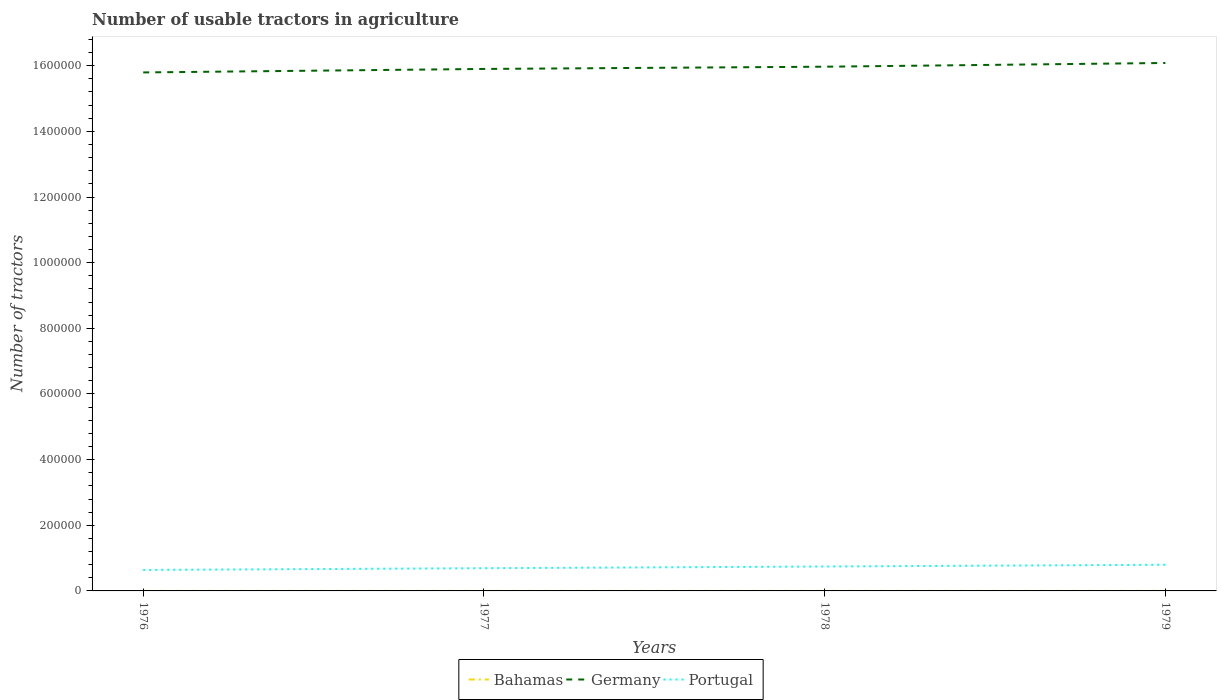How many different coloured lines are there?
Your response must be concise. 3. Does the line corresponding to Germany intersect with the line corresponding to Bahamas?
Your response must be concise. No. Is the number of lines equal to the number of legend labels?
Offer a terse response. Yes. Across all years, what is the maximum number of usable tractors in agriculture in Portugal?
Your answer should be very brief. 6.39e+04. In which year was the number of usable tractors in agriculture in Germany maximum?
Ensure brevity in your answer.  1976. What is the difference between the highest and the second highest number of usable tractors in agriculture in Portugal?
Keep it short and to the point. 1.58e+04. What is the difference between two consecutive major ticks on the Y-axis?
Give a very brief answer. 2.00e+05. Are the values on the major ticks of Y-axis written in scientific E-notation?
Your answer should be very brief. No. Does the graph contain any zero values?
Provide a short and direct response. No. Does the graph contain grids?
Keep it short and to the point. No. How many legend labels are there?
Provide a succinct answer. 3. What is the title of the graph?
Your answer should be very brief. Number of usable tractors in agriculture. What is the label or title of the X-axis?
Provide a short and direct response. Years. What is the label or title of the Y-axis?
Give a very brief answer. Number of tractors. What is the Number of tractors of Germany in 1976?
Offer a very short reply. 1.58e+06. What is the Number of tractors of Portugal in 1976?
Provide a succinct answer. 6.39e+04. What is the Number of tractors of Germany in 1977?
Offer a terse response. 1.59e+06. What is the Number of tractors of Portugal in 1977?
Offer a terse response. 6.92e+04. What is the Number of tractors in Bahamas in 1978?
Your answer should be very brief. 77. What is the Number of tractors of Germany in 1978?
Make the answer very short. 1.60e+06. What is the Number of tractors of Portugal in 1978?
Give a very brief answer. 7.44e+04. What is the Number of tractors of Germany in 1979?
Your response must be concise. 1.61e+06. What is the Number of tractors in Portugal in 1979?
Provide a succinct answer. 7.97e+04. Across all years, what is the maximum Number of tractors of Germany?
Ensure brevity in your answer.  1.61e+06. Across all years, what is the maximum Number of tractors of Portugal?
Offer a terse response. 7.97e+04. Across all years, what is the minimum Number of tractors in Germany?
Make the answer very short. 1.58e+06. Across all years, what is the minimum Number of tractors of Portugal?
Provide a succinct answer. 6.39e+04. What is the total Number of tractors in Bahamas in the graph?
Offer a very short reply. 302. What is the total Number of tractors of Germany in the graph?
Your response must be concise. 6.37e+06. What is the total Number of tractors in Portugal in the graph?
Offer a terse response. 2.87e+05. What is the difference between the Number of tractors in Germany in 1976 and that in 1977?
Offer a very short reply. -1.06e+04. What is the difference between the Number of tractors of Portugal in 1976 and that in 1977?
Offer a very short reply. -5300. What is the difference between the Number of tractors of Bahamas in 1976 and that in 1978?
Make the answer very short. -6. What is the difference between the Number of tractors in Germany in 1976 and that in 1978?
Make the answer very short. -1.74e+04. What is the difference between the Number of tractors in Portugal in 1976 and that in 1978?
Provide a short and direct response. -1.05e+04. What is the difference between the Number of tractors in Germany in 1976 and that in 1979?
Ensure brevity in your answer.  -2.88e+04. What is the difference between the Number of tractors in Portugal in 1976 and that in 1979?
Make the answer very short. -1.58e+04. What is the difference between the Number of tractors of Bahamas in 1977 and that in 1978?
Offer a very short reply. -3. What is the difference between the Number of tractors of Germany in 1977 and that in 1978?
Your response must be concise. -6809. What is the difference between the Number of tractors in Portugal in 1977 and that in 1978?
Offer a very short reply. -5200. What is the difference between the Number of tractors in Germany in 1977 and that in 1979?
Make the answer very short. -1.82e+04. What is the difference between the Number of tractors of Portugal in 1977 and that in 1979?
Provide a short and direct response. -1.05e+04. What is the difference between the Number of tractors of Bahamas in 1978 and that in 1979?
Your answer should be compact. -3. What is the difference between the Number of tractors in Germany in 1978 and that in 1979?
Provide a succinct answer. -1.14e+04. What is the difference between the Number of tractors in Portugal in 1978 and that in 1979?
Provide a short and direct response. -5300. What is the difference between the Number of tractors of Bahamas in 1976 and the Number of tractors of Germany in 1977?
Your answer should be compact. -1.59e+06. What is the difference between the Number of tractors of Bahamas in 1976 and the Number of tractors of Portugal in 1977?
Your answer should be very brief. -6.91e+04. What is the difference between the Number of tractors of Germany in 1976 and the Number of tractors of Portugal in 1977?
Give a very brief answer. 1.51e+06. What is the difference between the Number of tractors of Bahamas in 1976 and the Number of tractors of Germany in 1978?
Ensure brevity in your answer.  -1.60e+06. What is the difference between the Number of tractors of Bahamas in 1976 and the Number of tractors of Portugal in 1978?
Provide a short and direct response. -7.43e+04. What is the difference between the Number of tractors of Germany in 1976 and the Number of tractors of Portugal in 1978?
Provide a short and direct response. 1.51e+06. What is the difference between the Number of tractors in Bahamas in 1976 and the Number of tractors in Germany in 1979?
Make the answer very short. -1.61e+06. What is the difference between the Number of tractors of Bahamas in 1976 and the Number of tractors of Portugal in 1979?
Offer a very short reply. -7.96e+04. What is the difference between the Number of tractors in Germany in 1976 and the Number of tractors in Portugal in 1979?
Make the answer very short. 1.50e+06. What is the difference between the Number of tractors of Bahamas in 1977 and the Number of tractors of Germany in 1978?
Your answer should be compact. -1.60e+06. What is the difference between the Number of tractors in Bahamas in 1977 and the Number of tractors in Portugal in 1978?
Offer a terse response. -7.43e+04. What is the difference between the Number of tractors of Germany in 1977 and the Number of tractors of Portugal in 1978?
Your answer should be compact. 1.52e+06. What is the difference between the Number of tractors in Bahamas in 1977 and the Number of tractors in Germany in 1979?
Offer a very short reply. -1.61e+06. What is the difference between the Number of tractors of Bahamas in 1977 and the Number of tractors of Portugal in 1979?
Your answer should be very brief. -7.96e+04. What is the difference between the Number of tractors in Germany in 1977 and the Number of tractors in Portugal in 1979?
Offer a very short reply. 1.51e+06. What is the difference between the Number of tractors of Bahamas in 1978 and the Number of tractors of Germany in 1979?
Provide a succinct answer. -1.61e+06. What is the difference between the Number of tractors in Bahamas in 1978 and the Number of tractors in Portugal in 1979?
Provide a succinct answer. -7.96e+04. What is the difference between the Number of tractors in Germany in 1978 and the Number of tractors in Portugal in 1979?
Your answer should be very brief. 1.52e+06. What is the average Number of tractors in Bahamas per year?
Provide a succinct answer. 75.5. What is the average Number of tractors of Germany per year?
Your response must be concise. 1.59e+06. What is the average Number of tractors of Portugal per year?
Offer a terse response. 7.18e+04. In the year 1976, what is the difference between the Number of tractors of Bahamas and Number of tractors of Germany?
Your answer should be very brief. -1.58e+06. In the year 1976, what is the difference between the Number of tractors in Bahamas and Number of tractors in Portugal?
Provide a short and direct response. -6.38e+04. In the year 1976, what is the difference between the Number of tractors of Germany and Number of tractors of Portugal?
Your answer should be compact. 1.52e+06. In the year 1977, what is the difference between the Number of tractors of Bahamas and Number of tractors of Germany?
Your answer should be compact. -1.59e+06. In the year 1977, what is the difference between the Number of tractors of Bahamas and Number of tractors of Portugal?
Offer a terse response. -6.91e+04. In the year 1977, what is the difference between the Number of tractors of Germany and Number of tractors of Portugal?
Ensure brevity in your answer.  1.52e+06. In the year 1978, what is the difference between the Number of tractors of Bahamas and Number of tractors of Germany?
Make the answer very short. -1.60e+06. In the year 1978, what is the difference between the Number of tractors in Bahamas and Number of tractors in Portugal?
Ensure brevity in your answer.  -7.43e+04. In the year 1978, what is the difference between the Number of tractors in Germany and Number of tractors in Portugal?
Your answer should be very brief. 1.52e+06. In the year 1979, what is the difference between the Number of tractors of Bahamas and Number of tractors of Germany?
Your response must be concise. -1.61e+06. In the year 1979, what is the difference between the Number of tractors in Bahamas and Number of tractors in Portugal?
Give a very brief answer. -7.96e+04. In the year 1979, what is the difference between the Number of tractors of Germany and Number of tractors of Portugal?
Your answer should be very brief. 1.53e+06. What is the ratio of the Number of tractors of Bahamas in 1976 to that in 1977?
Offer a terse response. 0.96. What is the ratio of the Number of tractors of Germany in 1976 to that in 1977?
Keep it short and to the point. 0.99. What is the ratio of the Number of tractors in Portugal in 1976 to that in 1977?
Offer a very short reply. 0.92. What is the ratio of the Number of tractors of Bahamas in 1976 to that in 1978?
Offer a very short reply. 0.92. What is the ratio of the Number of tractors of Portugal in 1976 to that in 1978?
Provide a succinct answer. 0.86. What is the ratio of the Number of tractors of Bahamas in 1976 to that in 1979?
Keep it short and to the point. 0.89. What is the ratio of the Number of tractors of Germany in 1976 to that in 1979?
Ensure brevity in your answer.  0.98. What is the ratio of the Number of tractors in Portugal in 1976 to that in 1979?
Offer a very short reply. 0.8. What is the ratio of the Number of tractors of Portugal in 1977 to that in 1978?
Offer a very short reply. 0.93. What is the ratio of the Number of tractors of Bahamas in 1977 to that in 1979?
Offer a terse response. 0.93. What is the ratio of the Number of tractors of Germany in 1977 to that in 1979?
Give a very brief answer. 0.99. What is the ratio of the Number of tractors of Portugal in 1977 to that in 1979?
Make the answer very short. 0.87. What is the ratio of the Number of tractors of Bahamas in 1978 to that in 1979?
Give a very brief answer. 0.96. What is the ratio of the Number of tractors in Portugal in 1978 to that in 1979?
Provide a succinct answer. 0.93. What is the difference between the highest and the second highest Number of tractors in Bahamas?
Your answer should be compact. 3. What is the difference between the highest and the second highest Number of tractors in Germany?
Offer a very short reply. 1.14e+04. What is the difference between the highest and the second highest Number of tractors of Portugal?
Give a very brief answer. 5300. What is the difference between the highest and the lowest Number of tractors of Germany?
Your answer should be compact. 2.88e+04. What is the difference between the highest and the lowest Number of tractors in Portugal?
Give a very brief answer. 1.58e+04. 